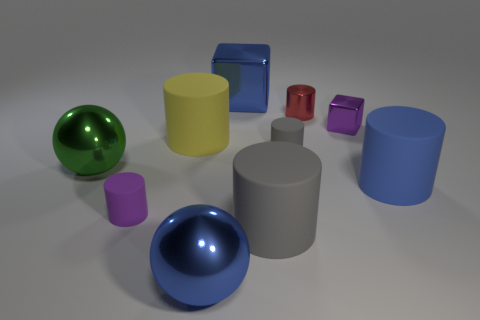How many small cylinders are both in front of the tiny metallic cube and right of the blue metallic block?
Make the answer very short. 1. Is the size of the blue matte object the same as the gray object behind the purple cylinder?
Provide a short and direct response. No. Are there any objects that are behind the big object on the right side of the block right of the large gray rubber cylinder?
Your answer should be very brief. Yes. There is a tiny purple thing that is behind the gray matte cylinder that is behind the large gray matte cylinder; what is its material?
Offer a terse response. Metal. What is the material of the blue thing that is to the left of the small shiny block and in front of the big yellow rubber object?
Keep it short and to the point. Metal. Is there a big blue rubber object of the same shape as the tiny red metallic thing?
Provide a succinct answer. Yes. There is a blue shiny object in front of the red object; are there any big blue blocks that are left of it?
Your answer should be compact. No. What number of blue things have the same material as the purple cylinder?
Ensure brevity in your answer.  1. Are there any blue shiny objects?
Ensure brevity in your answer.  Yes. What number of small rubber cylinders are the same color as the tiny metallic block?
Ensure brevity in your answer.  1. 